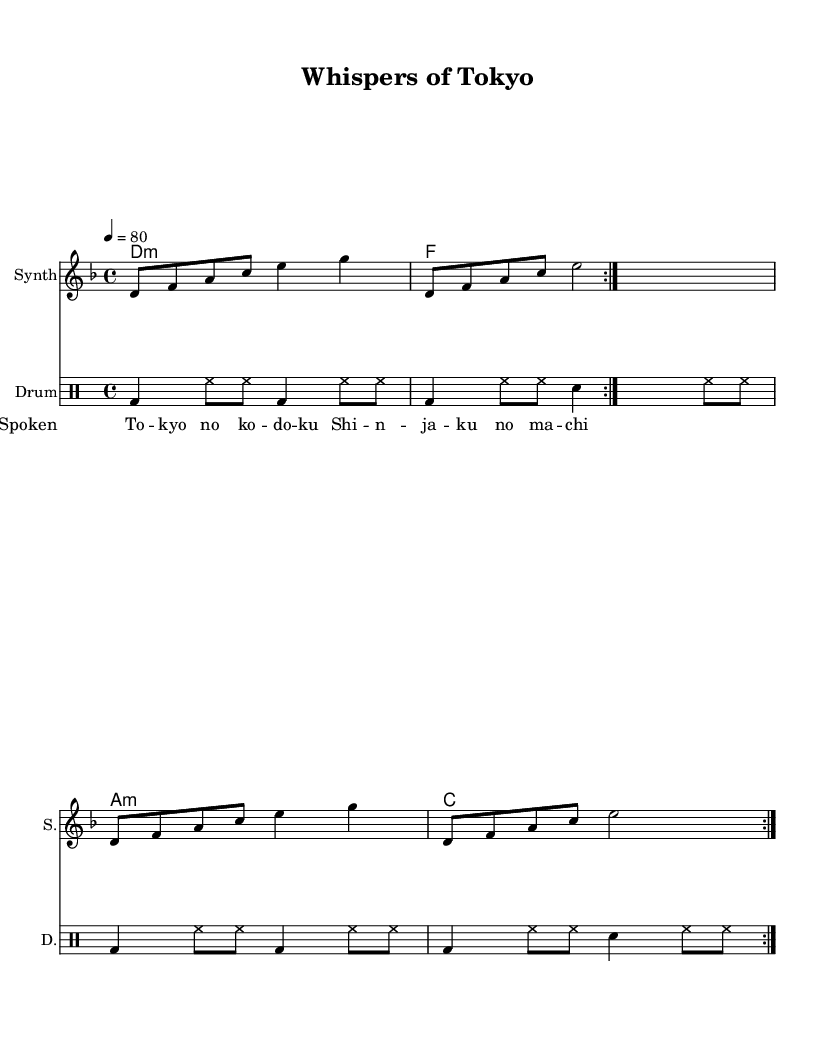What is the key signature of this music? The key signature indicated in the music is D minor, which has one flat (B flat).
Answer: D minor What is the time signature of this music? The time signature shown in the piece is 4/4, which means there are four beats in a measure and the quarter note gets one beat.
Answer: 4/4 What is the tempo of this piece? The tempo marking states that the piece is played at a speed of 80 beats per minute.
Answer: 80 How many times is the synth part repeated? The synth part is marked with a repeat sign and the indication 'volta 2', suggesting that the section is repeated two times.
Answer: 2 How many measures does the drum part have before repeating? By observing the drum part, each section consists of 4 measures before it repeats, as indicated by the repeat sign and the 'volta 2' markings.
Answer: 4 What type of muscial texture is primarily used in this piece? The combination of synth, spoken word, and drum creates an ambient texture that is characterized by layering, which is typical in experimental ambient dance music.
Answer: Ambient How do the spoken words contribute to the overall experience of this piece? The spoken word is intertwined with the music, adding a narrative layer that enhances the experiential quality and emotional depth of the ambient dance context.
Answer: Narrative 